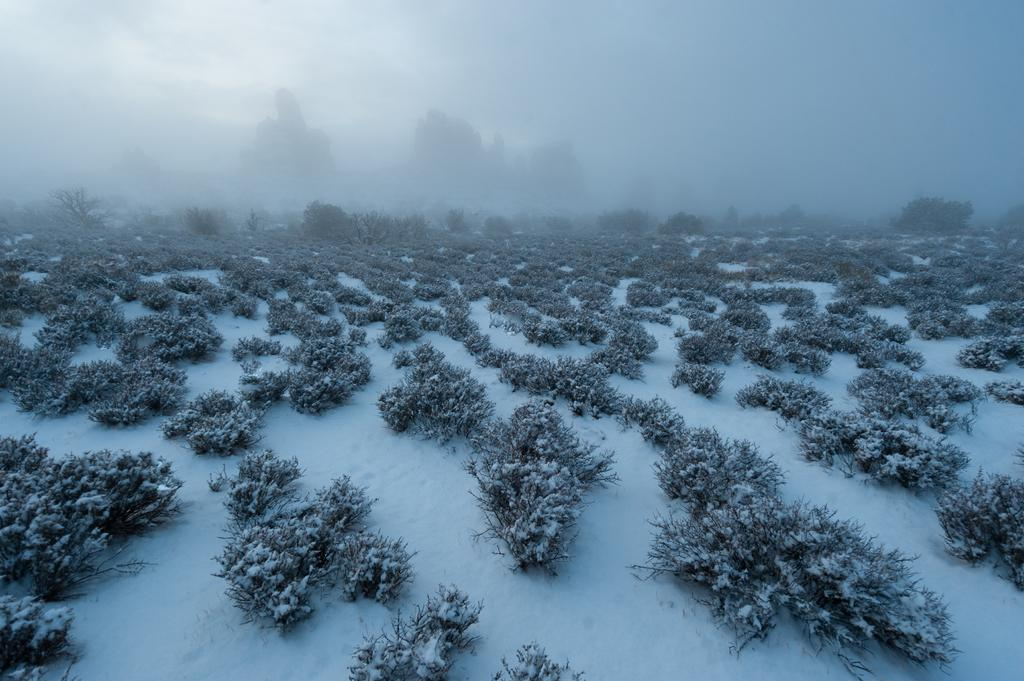Where was the picture taken? The picture was clicked outside. What can be seen in the foreground of the image? There are plants and snow in the foreground. What is visible in the background of the image? There is haze in the background, along with other unspecified items. Is the grandmother using a rake to clear the snow in the image? There is no grandmother or rake present in the image. 